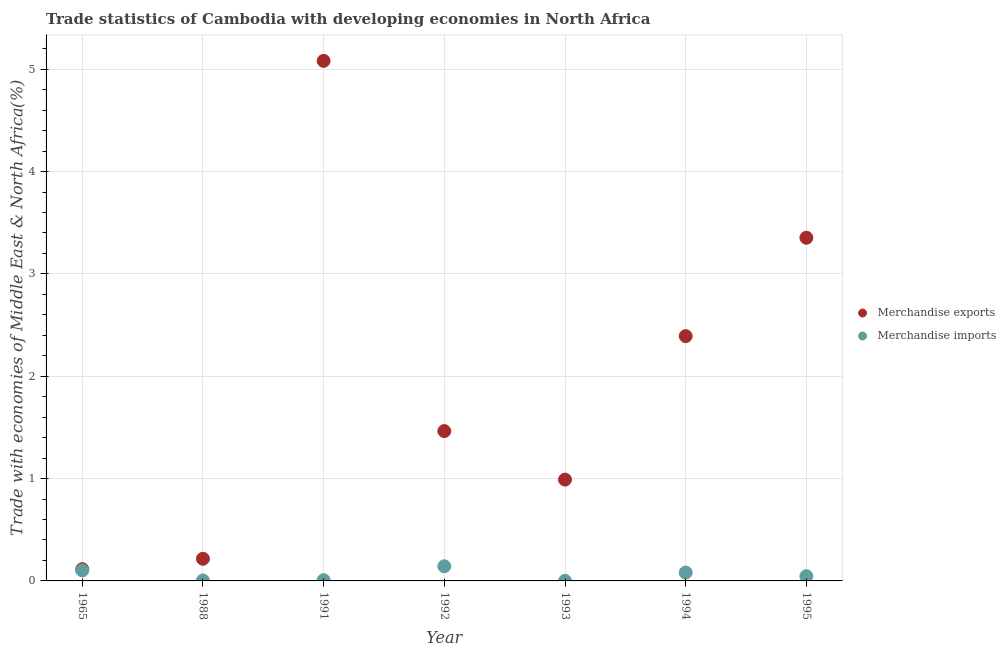Is the number of dotlines equal to the number of legend labels?
Offer a terse response. Yes. What is the merchandise exports in 1994?
Your answer should be compact. 2.39. Across all years, what is the maximum merchandise imports?
Provide a succinct answer. 0.14. Across all years, what is the minimum merchandise exports?
Offer a very short reply. 0.11. In which year was the merchandise imports maximum?
Offer a terse response. 1992. What is the total merchandise imports in the graph?
Offer a very short reply. 0.39. What is the difference between the merchandise imports in 1965 and that in 1993?
Provide a succinct answer. 0.1. What is the difference between the merchandise exports in 1993 and the merchandise imports in 1995?
Offer a terse response. 0.94. What is the average merchandise exports per year?
Your answer should be very brief. 1.94. In the year 1992, what is the difference between the merchandise exports and merchandise imports?
Offer a terse response. 1.32. In how many years, is the merchandise imports greater than 2.6 %?
Offer a very short reply. 0. What is the ratio of the merchandise exports in 1988 to that in 1994?
Provide a succinct answer. 0.09. Is the merchandise imports in 1993 less than that in 1995?
Your answer should be compact. Yes. Is the difference between the merchandise imports in 1965 and 1995 greater than the difference between the merchandise exports in 1965 and 1995?
Offer a very short reply. Yes. What is the difference between the highest and the second highest merchandise exports?
Provide a short and direct response. 1.73. What is the difference between the highest and the lowest merchandise imports?
Provide a short and direct response. 0.14. Is the merchandise imports strictly less than the merchandise exports over the years?
Provide a succinct answer. Yes. How many dotlines are there?
Offer a terse response. 2. Does the graph contain any zero values?
Your response must be concise. No. Where does the legend appear in the graph?
Your answer should be compact. Center right. How many legend labels are there?
Your answer should be very brief. 2. How are the legend labels stacked?
Your response must be concise. Vertical. What is the title of the graph?
Ensure brevity in your answer.  Trade statistics of Cambodia with developing economies in North Africa. What is the label or title of the Y-axis?
Ensure brevity in your answer.  Trade with economies of Middle East & North Africa(%). What is the Trade with economies of Middle East & North Africa(%) of Merchandise exports in 1965?
Your response must be concise. 0.11. What is the Trade with economies of Middle East & North Africa(%) of Merchandise imports in 1965?
Your answer should be compact. 0.1. What is the Trade with economies of Middle East & North Africa(%) of Merchandise exports in 1988?
Your response must be concise. 0.22. What is the Trade with economies of Middle East & North Africa(%) of Merchandise imports in 1988?
Your answer should be compact. 0. What is the Trade with economies of Middle East & North Africa(%) in Merchandise exports in 1991?
Keep it short and to the point. 5.08. What is the Trade with economies of Middle East & North Africa(%) of Merchandise imports in 1991?
Provide a succinct answer. 0.01. What is the Trade with economies of Middle East & North Africa(%) of Merchandise exports in 1992?
Your answer should be very brief. 1.46. What is the Trade with economies of Middle East & North Africa(%) of Merchandise imports in 1992?
Your response must be concise. 0.14. What is the Trade with economies of Middle East & North Africa(%) of Merchandise exports in 1993?
Offer a terse response. 0.99. What is the Trade with economies of Middle East & North Africa(%) of Merchandise imports in 1993?
Make the answer very short. 0. What is the Trade with economies of Middle East & North Africa(%) of Merchandise exports in 1994?
Provide a short and direct response. 2.39. What is the Trade with economies of Middle East & North Africa(%) in Merchandise imports in 1994?
Your answer should be compact. 0.08. What is the Trade with economies of Middle East & North Africa(%) of Merchandise exports in 1995?
Offer a terse response. 3.35. What is the Trade with economies of Middle East & North Africa(%) in Merchandise imports in 1995?
Offer a very short reply. 0.05. Across all years, what is the maximum Trade with economies of Middle East & North Africa(%) of Merchandise exports?
Provide a succinct answer. 5.08. Across all years, what is the maximum Trade with economies of Middle East & North Africa(%) in Merchandise imports?
Offer a very short reply. 0.14. Across all years, what is the minimum Trade with economies of Middle East & North Africa(%) of Merchandise exports?
Make the answer very short. 0.11. Across all years, what is the minimum Trade with economies of Middle East & North Africa(%) in Merchandise imports?
Your response must be concise. 0. What is the total Trade with economies of Middle East & North Africa(%) in Merchandise exports in the graph?
Keep it short and to the point. 13.61. What is the total Trade with economies of Middle East & North Africa(%) of Merchandise imports in the graph?
Provide a succinct answer. 0.39. What is the difference between the Trade with economies of Middle East & North Africa(%) of Merchandise exports in 1965 and that in 1988?
Provide a succinct answer. -0.1. What is the difference between the Trade with economies of Middle East & North Africa(%) in Merchandise imports in 1965 and that in 1988?
Your answer should be compact. 0.1. What is the difference between the Trade with economies of Middle East & North Africa(%) of Merchandise exports in 1965 and that in 1991?
Ensure brevity in your answer.  -4.97. What is the difference between the Trade with economies of Middle East & North Africa(%) in Merchandise imports in 1965 and that in 1991?
Provide a short and direct response. 0.1. What is the difference between the Trade with economies of Middle East & North Africa(%) in Merchandise exports in 1965 and that in 1992?
Your answer should be very brief. -1.35. What is the difference between the Trade with economies of Middle East & North Africa(%) of Merchandise imports in 1965 and that in 1992?
Offer a terse response. -0.04. What is the difference between the Trade with economies of Middle East & North Africa(%) of Merchandise exports in 1965 and that in 1993?
Provide a short and direct response. -0.88. What is the difference between the Trade with economies of Middle East & North Africa(%) of Merchandise imports in 1965 and that in 1993?
Provide a succinct answer. 0.1. What is the difference between the Trade with economies of Middle East & North Africa(%) of Merchandise exports in 1965 and that in 1994?
Make the answer very short. -2.28. What is the difference between the Trade with economies of Middle East & North Africa(%) in Merchandise imports in 1965 and that in 1994?
Offer a very short reply. 0.02. What is the difference between the Trade with economies of Middle East & North Africa(%) of Merchandise exports in 1965 and that in 1995?
Your response must be concise. -3.24. What is the difference between the Trade with economies of Middle East & North Africa(%) in Merchandise imports in 1965 and that in 1995?
Give a very brief answer. 0.06. What is the difference between the Trade with economies of Middle East & North Africa(%) in Merchandise exports in 1988 and that in 1991?
Your answer should be compact. -4.86. What is the difference between the Trade with economies of Middle East & North Africa(%) in Merchandise imports in 1988 and that in 1991?
Make the answer very short. -0. What is the difference between the Trade with economies of Middle East & North Africa(%) of Merchandise exports in 1988 and that in 1992?
Keep it short and to the point. -1.25. What is the difference between the Trade with economies of Middle East & North Africa(%) of Merchandise imports in 1988 and that in 1992?
Your answer should be compact. -0.14. What is the difference between the Trade with economies of Middle East & North Africa(%) of Merchandise exports in 1988 and that in 1993?
Ensure brevity in your answer.  -0.77. What is the difference between the Trade with economies of Middle East & North Africa(%) of Merchandise imports in 1988 and that in 1993?
Provide a short and direct response. 0. What is the difference between the Trade with economies of Middle East & North Africa(%) of Merchandise exports in 1988 and that in 1994?
Offer a terse response. -2.18. What is the difference between the Trade with economies of Middle East & North Africa(%) in Merchandise imports in 1988 and that in 1994?
Your answer should be compact. -0.08. What is the difference between the Trade with economies of Middle East & North Africa(%) of Merchandise exports in 1988 and that in 1995?
Provide a short and direct response. -3.14. What is the difference between the Trade with economies of Middle East & North Africa(%) of Merchandise imports in 1988 and that in 1995?
Ensure brevity in your answer.  -0.04. What is the difference between the Trade with economies of Middle East & North Africa(%) in Merchandise exports in 1991 and that in 1992?
Provide a short and direct response. 3.62. What is the difference between the Trade with economies of Middle East & North Africa(%) in Merchandise imports in 1991 and that in 1992?
Provide a succinct answer. -0.14. What is the difference between the Trade with economies of Middle East & North Africa(%) of Merchandise exports in 1991 and that in 1993?
Ensure brevity in your answer.  4.09. What is the difference between the Trade with economies of Middle East & North Africa(%) of Merchandise imports in 1991 and that in 1993?
Your answer should be very brief. 0.01. What is the difference between the Trade with economies of Middle East & North Africa(%) in Merchandise exports in 1991 and that in 1994?
Ensure brevity in your answer.  2.69. What is the difference between the Trade with economies of Middle East & North Africa(%) in Merchandise imports in 1991 and that in 1994?
Offer a terse response. -0.07. What is the difference between the Trade with economies of Middle East & North Africa(%) of Merchandise exports in 1991 and that in 1995?
Offer a very short reply. 1.73. What is the difference between the Trade with economies of Middle East & North Africa(%) in Merchandise imports in 1991 and that in 1995?
Offer a terse response. -0.04. What is the difference between the Trade with economies of Middle East & North Africa(%) in Merchandise exports in 1992 and that in 1993?
Keep it short and to the point. 0.47. What is the difference between the Trade with economies of Middle East & North Africa(%) of Merchandise imports in 1992 and that in 1993?
Provide a short and direct response. 0.14. What is the difference between the Trade with economies of Middle East & North Africa(%) of Merchandise exports in 1992 and that in 1994?
Provide a succinct answer. -0.93. What is the difference between the Trade with economies of Middle East & North Africa(%) of Merchandise imports in 1992 and that in 1994?
Your response must be concise. 0.06. What is the difference between the Trade with economies of Middle East & North Africa(%) in Merchandise exports in 1992 and that in 1995?
Provide a short and direct response. -1.89. What is the difference between the Trade with economies of Middle East & North Africa(%) in Merchandise imports in 1992 and that in 1995?
Your answer should be very brief. 0.1. What is the difference between the Trade with economies of Middle East & North Africa(%) in Merchandise exports in 1993 and that in 1994?
Make the answer very short. -1.4. What is the difference between the Trade with economies of Middle East & North Africa(%) of Merchandise imports in 1993 and that in 1994?
Offer a terse response. -0.08. What is the difference between the Trade with economies of Middle East & North Africa(%) in Merchandise exports in 1993 and that in 1995?
Your answer should be compact. -2.36. What is the difference between the Trade with economies of Middle East & North Africa(%) of Merchandise imports in 1993 and that in 1995?
Keep it short and to the point. -0.05. What is the difference between the Trade with economies of Middle East & North Africa(%) of Merchandise exports in 1994 and that in 1995?
Your response must be concise. -0.96. What is the difference between the Trade with economies of Middle East & North Africa(%) of Merchandise imports in 1994 and that in 1995?
Your response must be concise. 0.03. What is the difference between the Trade with economies of Middle East & North Africa(%) of Merchandise exports in 1965 and the Trade with economies of Middle East & North Africa(%) of Merchandise imports in 1988?
Your answer should be compact. 0.11. What is the difference between the Trade with economies of Middle East & North Africa(%) of Merchandise exports in 1965 and the Trade with economies of Middle East & North Africa(%) of Merchandise imports in 1991?
Give a very brief answer. 0.11. What is the difference between the Trade with economies of Middle East & North Africa(%) in Merchandise exports in 1965 and the Trade with economies of Middle East & North Africa(%) in Merchandise imports in 1992?
Your answer should be very brief. -0.03. What is the difference between the Trade with economies of Middle East & North Africa(%) in Merchandise exports in 1965 and the Trade with economies of Middle East & North Africa(%) in Merchandise imports in 1993?
Make the answer very short. 0.11. What is the difference between the Trade with economies of Middle East & North Africa(%) of Merchandise exports in 1965 and the Trade with economies of Middle East & North Africa(%) of Merchandise imports in 1994?
Offer a very short reply. 0.03. What is the difference between the Trade with economies of Middle East & North Africa(%) of Merchandise exports in 1965 and the Trade with economies of Middle East & North Africa(%) of Merchandise imports in 1995?
Keep it short and to the point. 0.07. What is the difference between the Trade with economies of Middle East & North Africa(%) in Merchandise exports in 1988 and the Trade with economies of Middle East & North Africa(%) in Merchandise imports in 1991?
Offer a terse response. 0.21. What is the difference between the Trade with economies of Middle East & North Africa(%) in Merchandise exports in 1988 and the Trade with economies of Middle East & North Africa(%) in Merchandise imports in 1992?
Your response must be concise. 0.07. What is the difference between the Trade with economies of Middle East & North Africa(%) in Merchandise exports in 1988 and the Trade with economies of Middle East & North Africa(%) in Merchandise imports in 1993?
Offer a very short reply. 0.22. What is the difference between the Trade with economies of Middle East & North Africa(%) in Merchandise exports in 1988 and the Trade with economies of Middle East & North Africa(%) in Merchandise imports in 1994?
Keep it short and to the point. 0.14. What is the difference between the Trade with economies of Middle East & North Africa(%) in Merchandise exports in 1988 and the Trade with economies of Middle East & North Africa(%) in Merchandise imports in 1995?
Provide a succinct answer. 0.17. What is the difference between the Trade with economies of Middle East & North Africa(%) of Merchandise exports in 1991 and the Trade with economies of Middle East & North Africa(%) of Merchandise imports in 1992?
Keep it short and to the point. 4.94. What is the difference between the Trade with economies of Middle East & North Africa(%) in Merchandise exports in 1991 and the Trade with economies of Middle East & North Africa(%) in Merchandise imports in 1993?
Ensure brevity in your answer.  5.08. What is the difference between the Trade with economies of Middle East & North Africa(%) of Merchandise exports in 1991 and the Trade with economies of Middle East & North Africa(%) of Merchandise imports in 1994?
Your answer should be compact. 5. What is the difference between the Trade with economies of Middle East & North Africa(%) of Merchandise exports in 1991 and the Trade with economies of Middle East & North Africa(%) of Merchandise imports in 1995?
Keep it short and to the point. 5.03. What is the difference between the Trade with economies of Middle East & North Africa(%) of Merchandise exports in 1992 and the Trade with economies of Middle East & North Africa(%) of Merchandise imports in 1993?
Keep it short and to the point. 1.46. What is the difference between the Trade with economies of Middle East & North Africa(%) of Merchandise exports in 1992 and the Trade with economies of Middle East & North Africa(%) of Merchandise imports in 1994?
Your answer should be very brief. 1.38. What is the difference between the Trade with economies of Middle East & North Africa(%) of Merchandise exports in 1992 and the Trade with economies of Middle East & North Africa(%) of Merchandise imports in 1995?
Ensure brevity in your answer.  1.42. What is the difference between the Trade with economies of Middle East & North Africa(%) in Merchandise exports in 1993 and the Trade with economies of Middle East & North Africa(%) in Merchandise imports in 1994?
Provide a succinct answer. 0.91. What is the difference between the Trade with economies of Middle East & North Africa(%) in Merchandise exports in 1993 and the Trade with economies of Middle East & North Africa(%) in Merchandise imports in 1995?
Provide a succinct answer. 0.94. What is the difference between the Trade with economies of Middle East & North Africa(%) in Merchandise exports in 1994 and the Trade with economies of Middle East & North Africa(%) in Merchandise imports in 1995?
Ensure brevity in your answer.  2.35. What is the average Trade with economies of Middle East & North Africa(%) of Merchandise exports per year?
Keep it short and to the point. 1.94. What is the average Trade with economies of Middle East & North Africa(%) of Merchandise imports per year?
Ensure brevity in your answer.  0.06. In the year 1965, what is the difference between the Trade with economies of Middle East & North Africa(%) in Merchandise exports and Trade with economies of Middle East & North Africa(%) in Merchandise imports?
Give a very brief answer. 0.01. In the year 1988, what is the difference between the Trade with economies of Middle East & North Africa(%) of Merchandise exports and Trade with economies of Middle East & North Africa(%) of Merchandise imports?
Your answer should be very brief. 0.21. In the year 1991, what is the difference between the Trade with economies of Middle East & North Africa(%) of Merchandise exports and Trade with economies of Middle East & North Africa(%) of Merchandise imports?
Provide a succinct answer. 5.07. In the year 1992, what is the difference between the Trade with economies of Middle East & North Africa(%) of Merchandise exports and Trade with economies of Middle East & North Africa(%) of Merchandise imports?
Your response must be concise. 1.32. In the year 1994, what is the difference between the Trade with economies of Middle East & North Africa(%) of Merchandise exports and Trade with economies of Middle East & North Africa(%) of Merchandise imports?
Ensure brevity in your answer.  2.31. In the year 1995, what is the difference between the Trade with economies of Middle East & North Africa(%) in Merchandise exports and Trade with economies of Middle East & North Africa(%) in Merchandise imports?
Offer a very short reply. 3.31. What is the ratio of the Trade with economies of Middle East & North Africa(%) in Merchandise exports in 1965 to that in 1988?
Your answer should be very brief. 0.53. What is the ratio of the Trade with economies of Middle East & North Africa(%) of Merchandise imports in 1965 to that in 1988?
Provide a succinct answer. 24.28. What is the ratio of the Trade with economies of Middle East & North Africa(%) in Merchandise exports in 1965 to that in 1991?
Ensure brevity in your answer.  0.02. What is the ratio of the Trade with economies of Middle East & North Africa(%) in Merchandise imports in 1965 to that in 1991?
Ensure brevity in your answer.  14.07. What is the ratio of the Trade with economies of Middle East & North Africa(%) in Merchandise exports in 1965 to that in 1992?
Ensure brevity in your answer.  0.08. What is the ratio of the Trade with economies of Middle East & North Africa(%) in Merchandise imports in 1965 to that in 1992?
Your answer should be compact. 0.72. What is the ratio of the Trade with economies of Middle East & North Africa(%) of Merchandise exports in 1965 to that in 1993?
Make the answer very short. 0.12. What is the ratio of the Trade with economies of Middle East & North Africa(%) in Merchandise imports in 1965 to that in 1993?
Your answer should be very brief. 359.37. What is the ratio of the Trade with economies of Middle East & North Africa(%) of Merchandise exports in 1965 to that in 1994?
Offer a terse response. 0.05. What is the ratio of the Trade with economies of Middle East & North Africa(%) in Merchandise imports in 1965 to that in 1994?
Give a very brief answer. 1.26. What is the ratio of the Trade with economies of Middle East & North Africa(%) of Merchandise exports in 1965 to that in 1995?
Make the answer very short. 0.03. What is the ratio of the Trade with economies of Middle East & North Africa(%) of Merchandise imports in 1965 to that in 1995?
Ensure brevity in your answer.  2.21. What is the ratio of the Trade with economies of Middle East & North Africa(%) of Merchandise exports in 1988 to that in 1991?
Make the answer very short. 0.04. What is the ratio of the Trade with economies of Middle East & North Africa(%) in Merchandise imports in 1988 to that in 1991?
Make the answer very short. 0.58. What is the ratio of the Trade with economies of Middle East & North Africa(%) of Merchandise exports in 1988 to that in 1992?
Your answer should be very brief. 0.15. What is the ratio of the Trade with economies of Middle East & North Africa(%) of Merchandise imports in 1988 to that in 1992?
Your answer should be very brief. 0.03. What is the ratio of the Trade with economies of Middle East & North Africa(%) of Merchandise exports in 1988 to that in 1993?
Offer a very short reply. 0.22. What is the ratio of the Trade with economies of Middle East & North Africa(%) in Merchandise imports in 1988 to that in 1993?
Provide a short and direct response. 14.8. What is the ratio of the Trade with economies of Middle East & North Africa(%) in Merchandise exports in 1988 to that in 1994?
Ensure brevity in your answer.  0.09. What is the ratio of the Trade with economies of Middle East & North Africa(%) in Merchandise imports in 1988 to that in 1994?
Provide a short and direct response. 0.05. What is the ratio of the Trade with economies of Middle East & North Africa(%) in Merchandise exports in 1988 to that in 1995?
Your answer should be very brief. 0.06. What is the ratio of the Trade with economies of Middle East & North Africa(%) of Merchandise imports in 1988 to that in 1995?
Your answer should be very brief. 0.09. What is the ratio of the Trade with economies of Middle East & North Africa(%) in Merchandise exports in 1991 to that in 1992?
Your response must be concise. 3.47. What is the ratio of the Trade with economies of Middle East & North Africa(%) of Merchandise imports in 1991 to that in 1992?
Your response must be concise. 0.05. What is the ratio of the Trade with economies of Middle East & North Africa(%) in Merchandise exports in 1991 to that in 1993?
Your answer should be compact. 5.13. What is the ratio of the Trade with economies of Middle East & North Africa(%) in Merchandise imports in 1991 to that in 1993?
Give a very brief answer. 25.55. What is the ratio of the Trade with economies of Middle East & North Africa(%) of Merchandise exports in 1991 to that in 1994?
Your answer should be compact. 2.12. What is the ratio of the Trade with economies of Middle East & North Africa(%) in Merchandise imports in 1991 to that in 1994?
Your answer should be compact. 0.09. What is the ratio of the Trade with economies of Middle East & North Africa(%) in Merchandise exports in 1991 to that in 1995?
Offer a very short reply. 1.52. What is the ratio of the Trade with economies of Middle East & North Africa(%) of Merchandise imports in 1991 to that in 1995?
Give a very brief answer. 0.16. What is the ratio of the Trade with economies of Middle East & North Africa(%) of Merchandise exports in 1992 to that in 1993?
Provide a succinct answer. 1.48. What is the ratio of the Trade with economies of Middle East & North Africa(%) in Merchandise imports in 1992 to that in 1993?
Offer a terse response. 499.48. What is the ratio of the Trade with economies of Middle East & North Africa(%) in Merchandise exports in 1992 to that in 1994?
Keep it short and to the point. 0.61. What is the ratio of the Trade with economies of Middle East & North Africa(%) of Merchandise imports in 1992 to that in 1994?
Your answer should be compact. 1.76. What is the ratio of the Trade with economies of Middle East & North Africa(%) of Merchandise exports in 1992 to that in 1995?
Provide a short and direct response. 0.44. What is the ratio of the Trade with economies of Middle East & North Africa(%) in Merchandise imports in 1992 to that in 1995?
Offer a terse response. 3.07. What is the ratio of the Trade with economies of Middle East & North Africa(%) in Merchandise exports in 1993 to that in 1994?
Your response must be concise. 0.41. What is the ratio of the Trade with economies of Middle East & North Africa(%) in Merchandise imports in 1993 to that in 1994?
Ensure brevity in your answer.  0. What is the ratio of the Trade with economies of Middle East & North Africa(%) of Merchandise exports in 1993 to that in 1995?
Your response must be concise. 0.3. What is the ratio of the Trade with economies of Middle East & North Africa(%) in Merchandise imports in 1993 to that in 1995?
Offer a terse response. 0.01. What is the ratio of the Trade with economies of Middle East & North Africa(%) of Merchandise exports in 1994 to that in 1995?
Keep it short and to the point. 0.71. What is the ratio of the Trade with economies of Middle East & North Africa(%) of Merchandise imports in 1994 to that in 1995?
Provide a succinct answer. 1.75. What is the difference between the highest and the second highest Trade with economies of Middle East & North Africa(%) of Merchandise exports?
Your answer should be compact. 1.73. What is the difference between the highest and the second highest Trade with economies of Middle East & North Africa(%) of Merchandise imports?
Ensure brevity in your answer.  0.04. What is the difference between the highest and the lowest Trade with economies of Middle East & North Africa(%) in Merchandise exports?
Keep it short and to the point. 4.97. What is the difference between the highest and the lowest Trade with economies of Middle East & North Africa(%) of Merchandise imports?
Make the answer very short. 0.14. 